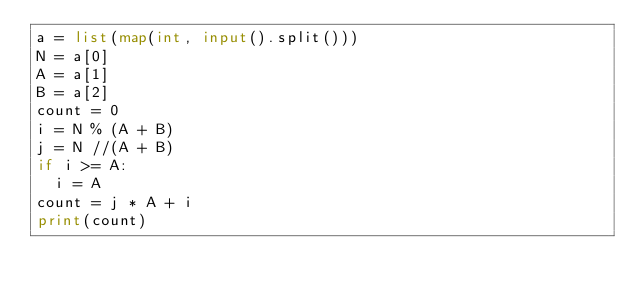Convert code to text. <code><loc_0><loc_0><loc_500><loc_500><_Python_>a = list(map(int, input().split()))
N = a[0]
A = a[1]
B = a[2]
count = 0
i = N % (A + B) 
j = N //(A + B)
if i >= A:
  i = A
count = j * A + i
print(count)</code> 